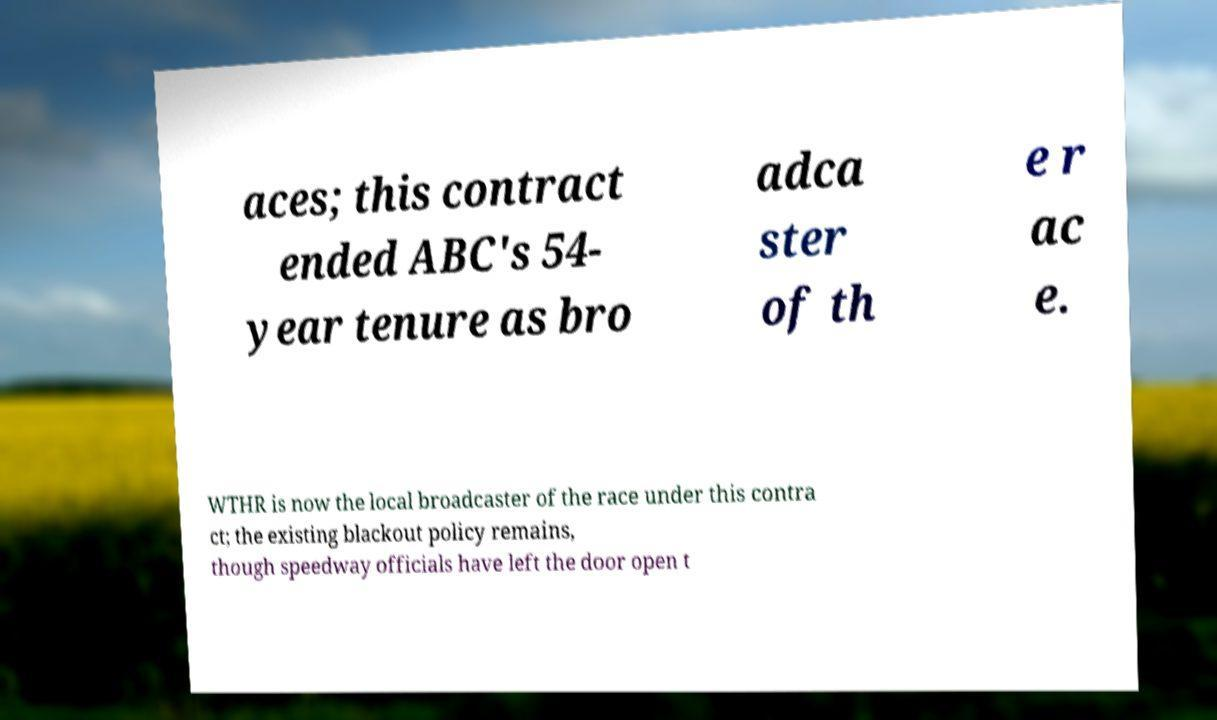What messages or text are displayed in this image? I need them in a readable, typed format. aces; this contract ended ABC's 54- year tenure as bro adca ster of th e r ac e. WTHR is now the local broadcaster of the race under this contra ct; the existing blackout policy remains, though speedway officials have left the door open t 